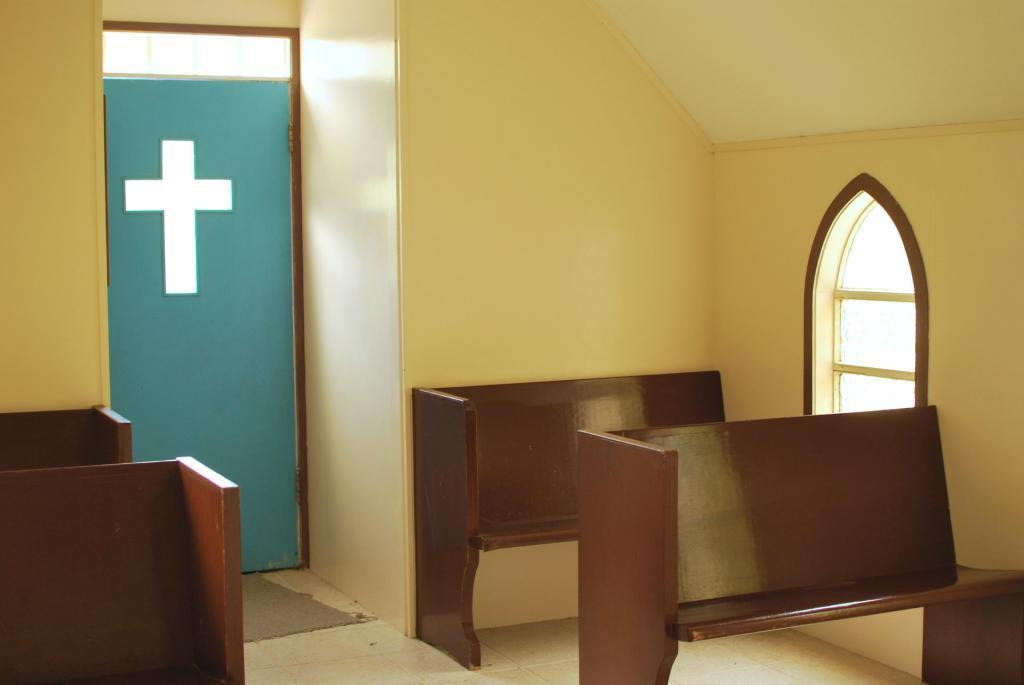What is the setting of the image? The image depicts the inside of a room. What type of furniture is present in the room? There are benches in the room. Is there any means of entering or exiting the room? Yes, there is a door in the room. What color is the copper veil hanging in the room? There is no copper veil present in the image; the image only depicts a room with benches and a door. 